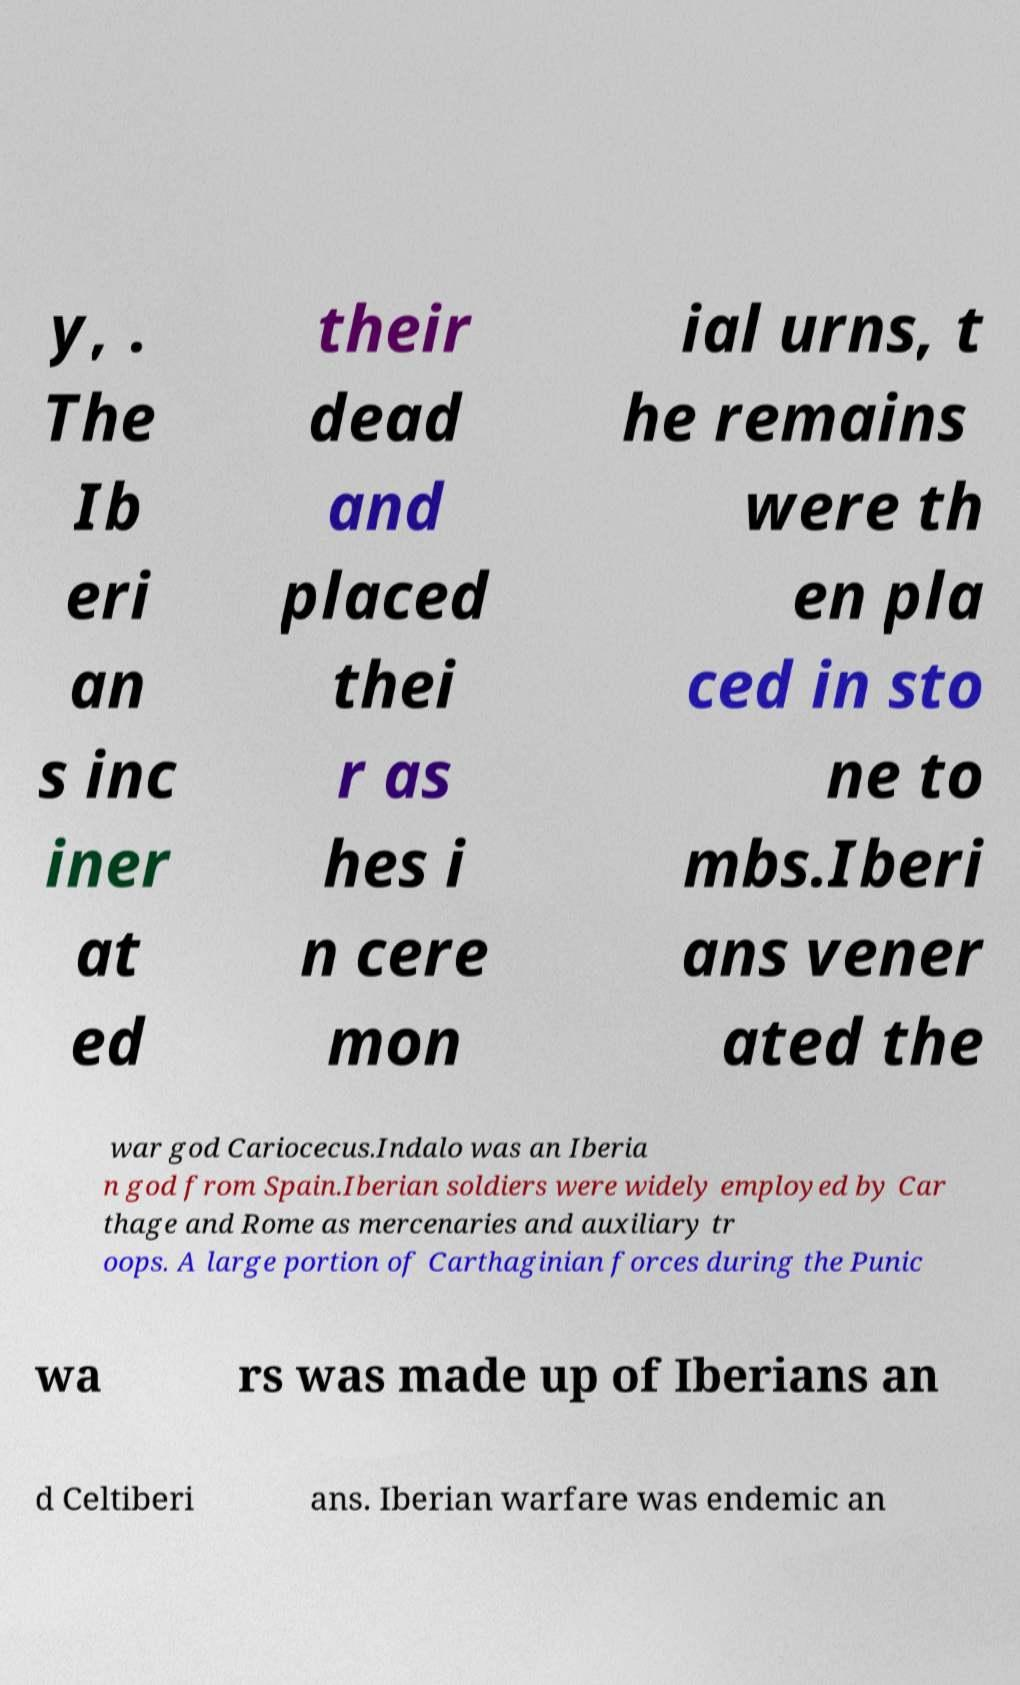Please read and relay the text visible in this image. What does it say? y, . The Ib eri an s inc iner at ed their dead and placed thei r as hes i n cere mon ial urns, t he remains were th en pla ced in sto ne to mbs.Iberi ans vener ated the war god Cariocecus.Indalo was an Iberia n god from Spain.Iberian soldiers were widely employed by Car thage and Rome as mercenaries and auxiliary tr oops. A large portion of Carthaginian forces during the Punic wa rs was made up of Iberians an d Celtiberi ans. Iberian warfare was endemic an 